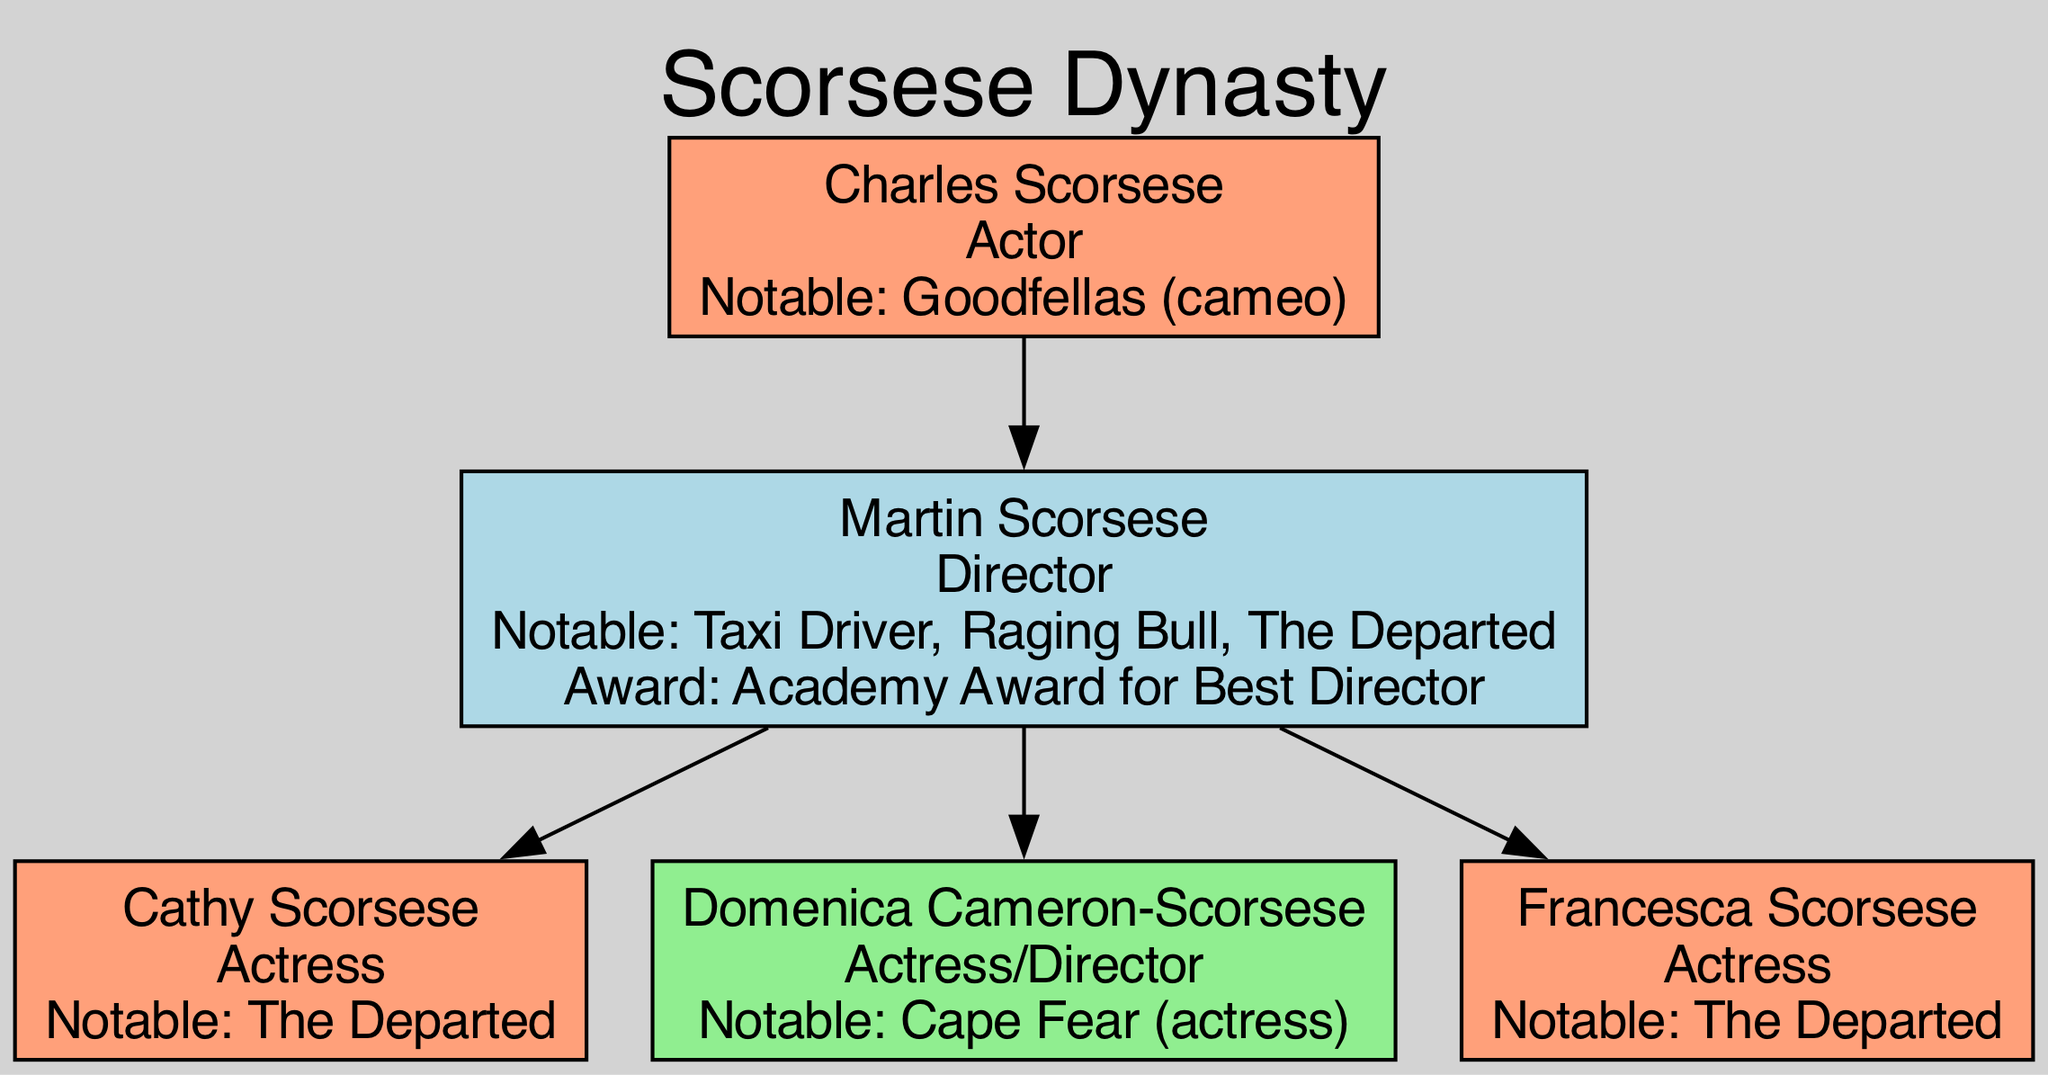What is the profession of Martin Scorsese? In the diagram, Martin Scorsese is clearly listed as a "Director" under his name.
Answer: Director How many children does Martin Scorsese have? By examining the relationships in the diagram, Martin Scorsese is shown to have three children: Cathy Scorsese, Domenica Cameron-Scorsese, and Francesca Scorsese. Therefore, the total count is 3.
Answer: 3 What is the notable work of Charles Scorsese? The diagram indicates that the notable work of Charles Scorsese is "Goodfellas (cameo)" stated directly under his profession.
Answer: Goodfellas (cameo) Who is the parent of Cathy Scorsese? The relationships section shows that Martin Scorsese is listed as a parent to Cathy Scorsese, establishing a direct lineage.
Answer: Martin Scorsese Which profession is associated with Francesca Scorsese? Francesca Scorsese's profession is indicated as "Actress" in the node that represents her in the diagram.
Answer: Actress How many generations are represented in the diagram? The diagram outlines two generations: the grandparents (Charles Scorsese) and the grandchildren (Martin Scorsese and his children). Hence, there are 2 generations visible.
Answer: 2 What award did Martin Scorsese win? In the details for Martin Scorsese, it is noted that he won the "Academy Award for Best Director", directly answering the question regarding his accolades.
Answer: Academy Award for Best Director Is Domenica Cameron-Scorsese a director? The diagram specifically lists Domenica Cameron-Scorsese as both an "Actress" and "Director", confirming her multifaceted roles in the film industry.
Answer: Yes What notable work is shared by multiple family members? In the diagram, the notable work "The Departed" is associated with three individuals: Martin Scorsese, Cathy Scorsese, and Francesca Scorsese, indicating a shared film among them.
Answer: The Departed 